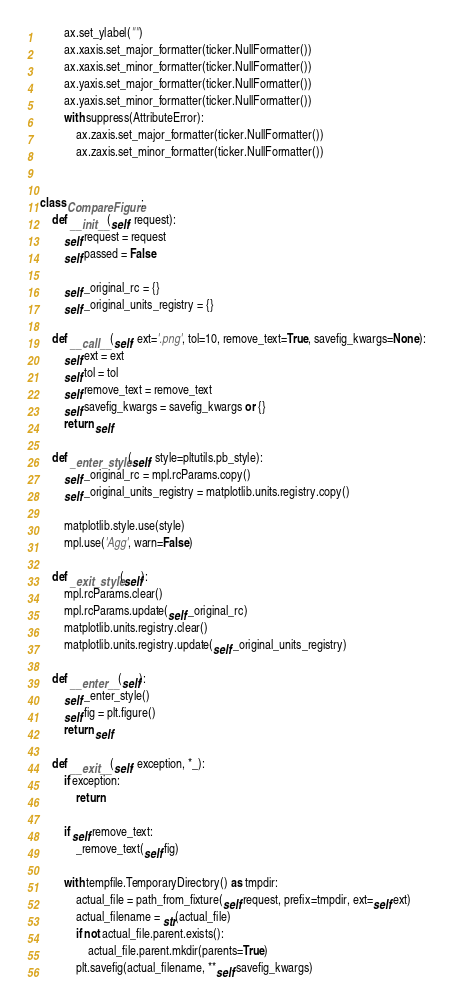<code> <loc_0><loc_0><loc_500><loc_500><_Python_>        ax.set_ylabel("")
        ax.xaxis.set_major_formatter(ticker.NullFormatter())
        ax.xaxis.set_minor_formatter(ticker.NullFormatter())
        ax.yaxis.set_major_formatter(ticker.NullFormatter())
        ax.yaxis.set_minor_formatter(ticker.NullFormatter())
        with suppress(AttributeError):
            ax.zaxis.set_major_formatter(ticker.NullFormatter())
            ax.zaxis.set_minor_formatter(ticker.NullFormatter())


class CompareFigure:
    def __init__(self, request):
        self.request = request
        self.passed = False

        self._original_rc = {}
        self._original_units_registry = {}

    def __call__(self, ext='.png', tol=10, remove_text=True, savefig_kwargs=None):
        self.ext = ext
        self.tol = tol
        self.remove_text = remove_text
        self.savefig_kwargs = savefig_kwargs or {}
        return self

    def _enter_style(self, style=pltutils.pb_style):
        self._original_rc = mpl.rcParams.copy()
        self._original_units_registry = matplotlib.units.registry.copy()

        matplotlib.style.use(style)
        mpl.use('Agg', warn=False)

    def _exit_style(self):
        mpl.rcParams.clear()
        mpl.rcParams.update(self._original_rc)
        matplotlib.units.registry.clear()
        matplotlib.units.registry.update(self._original_units_registry)

    def __enter__(self):
        self._enter_style()
        self.fig = plt.figure()
        return self

    def __exit__(self, exception, *_):
        if exception:
            return

        if self.remove_text:
            _remove_text(self.fig)

        with tempfile.TemporaryDirectory() as tmpdir:
            actual_file = path_from_fixture(self.request, prefix=tmpdir, ext=self.ext)
            actual_filename = str(actual_file)
            if not actual_file.parent.exists():
                actual_file.parent.mkdir(parents=True)
            plt.savefig(actual_filename, **self.savefig_kwargs)
</code> 